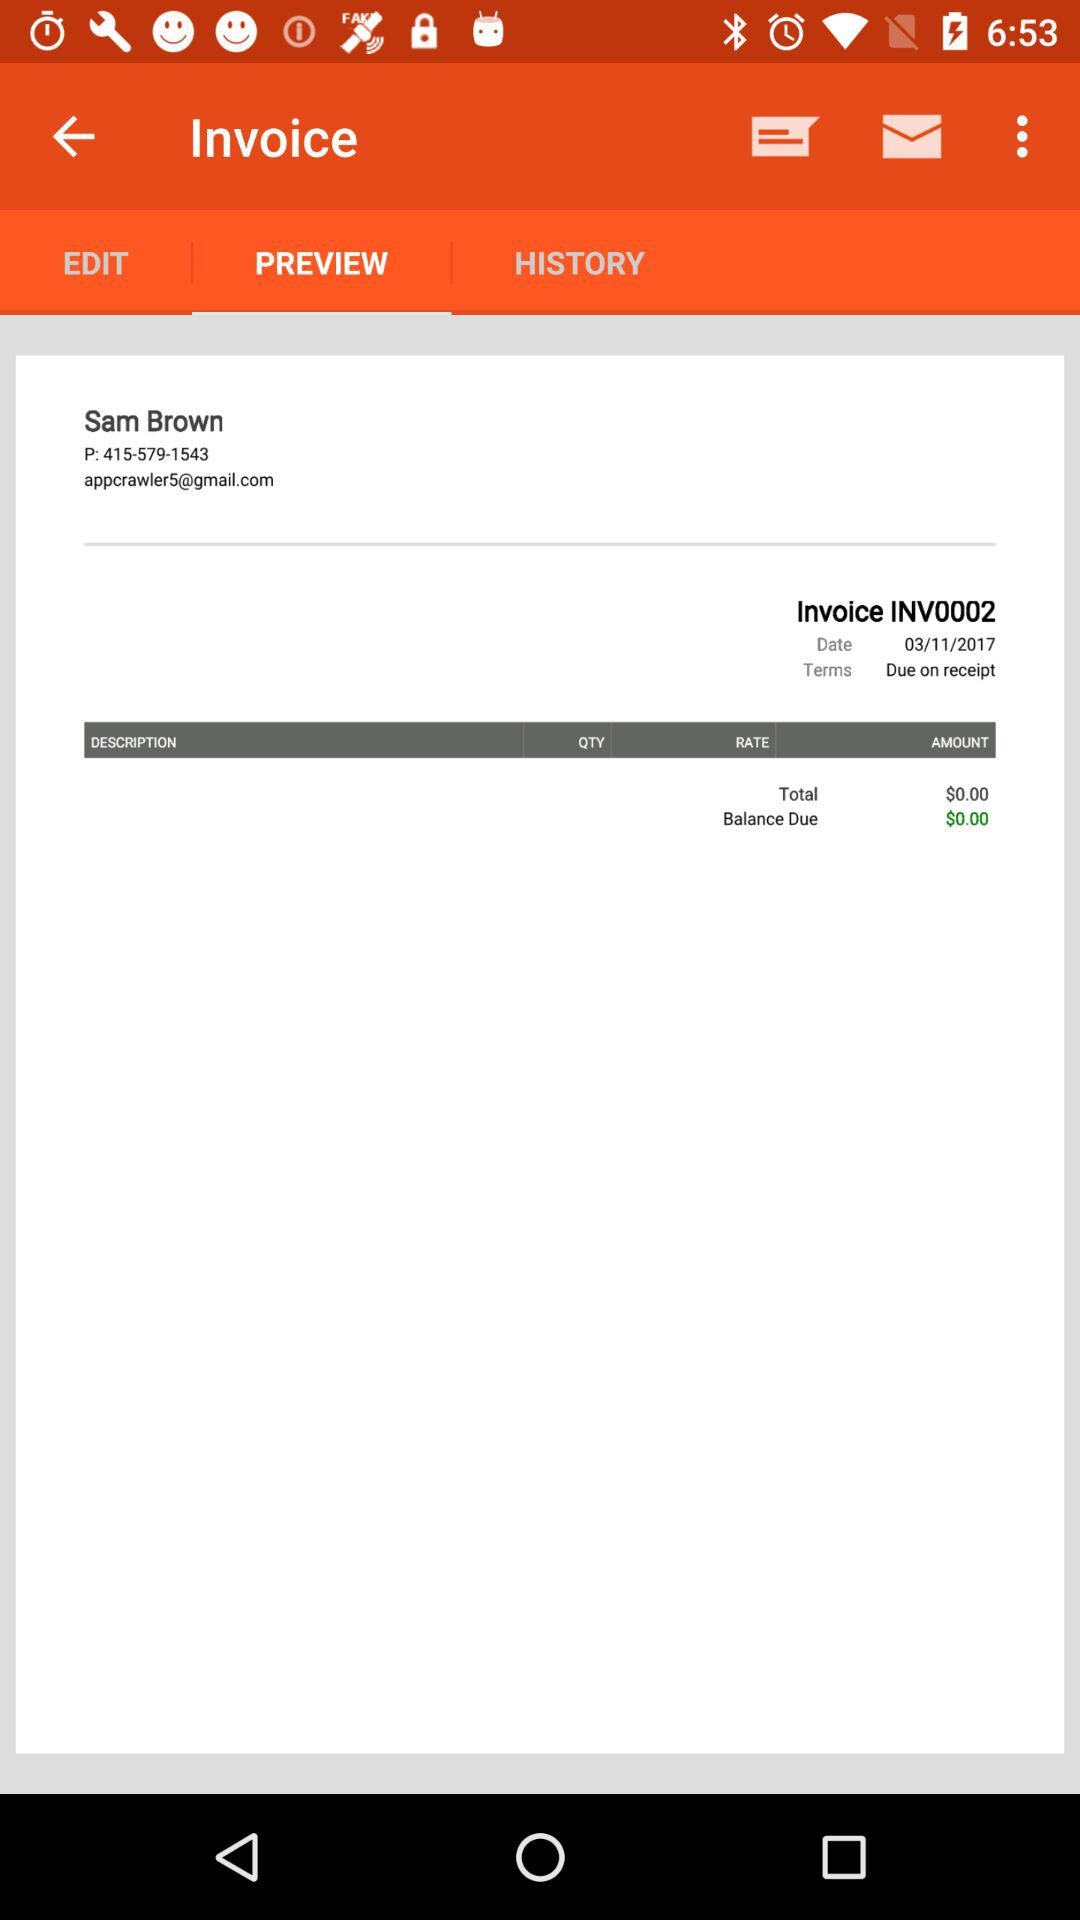What is the total amount of the invoice?
Answer the question using a single word or phrase. $0.00 